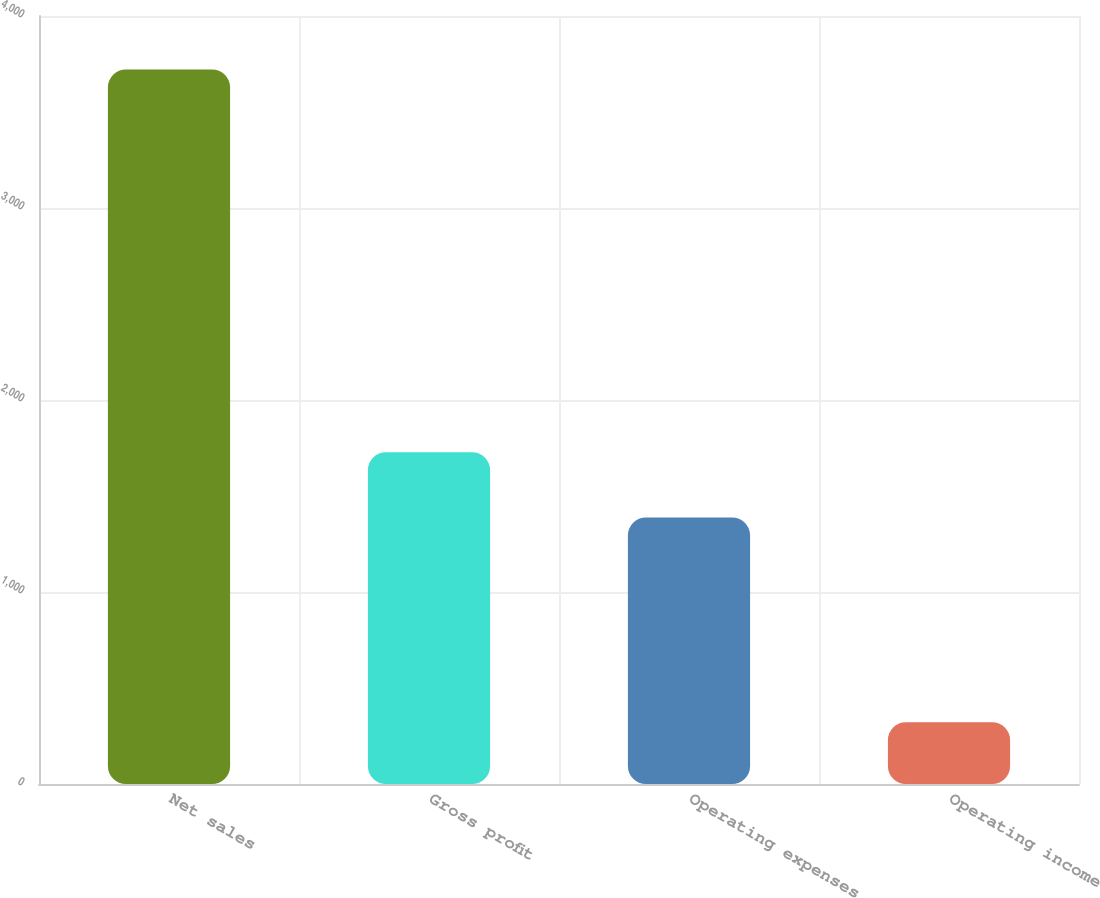Convert chart. <chart><loc_0><loc_0><loc_500><loc_500><bar_chart><fcel>Net sales<fcel>Gross profit<fcel>Operating expenses<fcel>Operating income<nl><fcel>3722<fcel>1728<fcel>1388<fcel>322<nl></chart> 